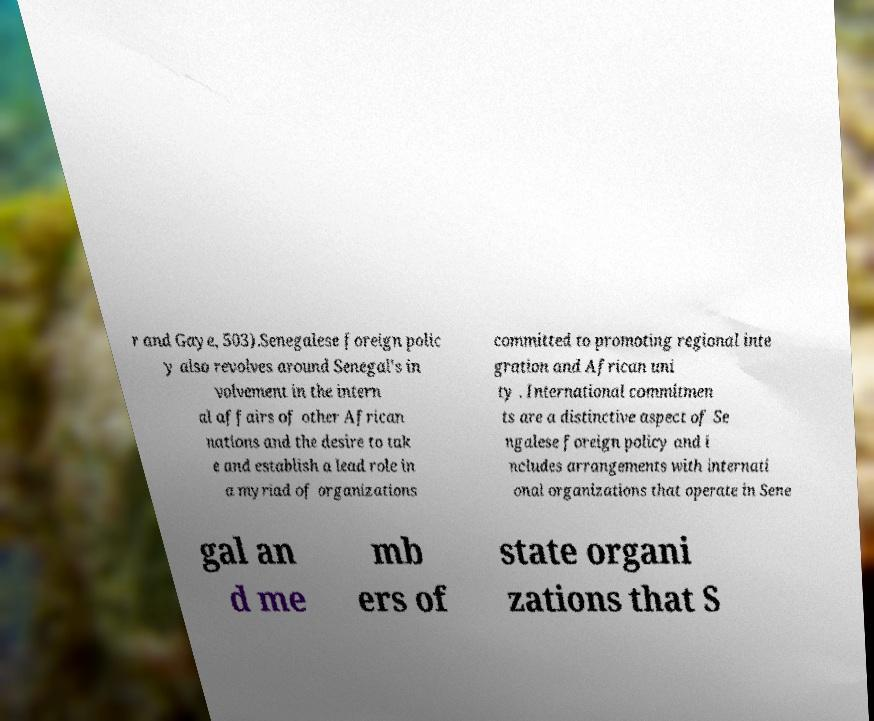Can you read and provide the text displayed in the image?This photo seems to have some interesting text. Can you extract and type it out for me? r and Gaye, 503).Senegalese foreign polic y also revolves around Senegal's in volvement in the intern al affairs of other African nations and the desire to tak e and establish a lead role in a myriad of organizations committed to promoting regional inte gration and African uni ty . International commitmen ts are a distinctive aspect of Se ngalese foreign policy and i ncludes arrangements with internati onal organizations that operate in Sene gal an d me mb ers of state organi zations that S 